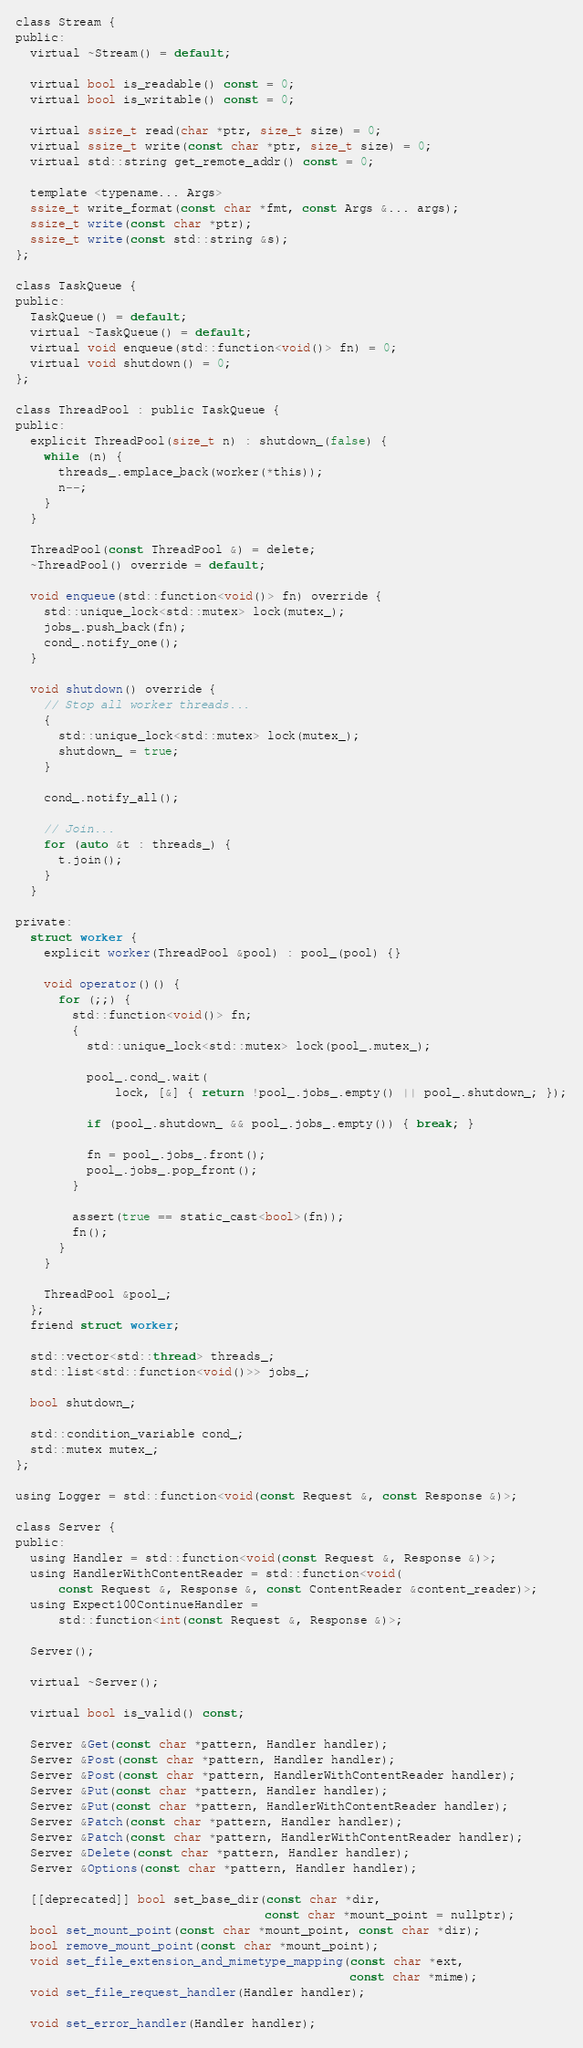Convert code to text. <code><loc_0><loc_0><loc_500><loc_500><_C_>class Stream {
public:
  virtual ~Stream() = default;

  virtual bool is_readable() const = 0;
  virtual bool is_writable() const = 0;

  virtual ssize_t read(char *ptr, size_t size) = 0;
  virtual ssize_t write(const char *ptr, size_t size) = 0;
  virtual std::string get_remote_addr() const = 0;

  template <typename... Args>
  ssize_t write_format(const char *fmt, const Args &... args);
  ssize_t write(const char *ptr);
  ssize_t write(const std::string &s);
};

class TaskQueue {
public:
  TaskQueue() = default;
  virtual ~TaskQueue() = default;
  virtual void enqueue(std::function<void()> fn) = 0;
  virtual void shutdown() = 0;
};

class ThreadPool : public TaskQueue {
public:
  explicit ThreadPool(size_t n) : shutdown_(false) {
    while (n) {
      threads_.emplace_back(worker(*this));
      n--;
    }
  }

  ThreadPool(const ThreadPool &) = delete;
  ~ThreadPool() override = default;

  void enqueue(std::function<void()> fn) override {
    std::unique_lock<std::mutex> lock(mutex_);
    jobs_.push_back(fn);
    cond_.notify_one();
  }

  void shutdown() override {
    // Stop all worker threads...
    {
      std::unique_lock<std::mutex> lock(mutex_);
      shutdown_ = true;
    }

    cond_.notify_all();

    // Join...
    for (auto &t : threads_) {
      t.join();
    }
  }

private:
  struct worker {
    explicit worker(ThreadPool &pool) : pool_(pool) {}

    void operator()() {
      for (;;) {
        std::function<void()> fn;
        {
          std::unique_lock<std::mutex> lock(pool_.mutex_);

          pool_.cond_.wait(
              lock, [&] { return !pool_.jobs_.empty() || pool_.shutdown_; });

          if (pool_.shutdown_ && pool_.jobs_.empty()) { break; }

          fn = pool_.jobs_.front();
          pool_.jobs_.pop_front();
        }

        assert(true == static_cast<bool>(fn));
        fn();
      }
    }

    ThreadPool &pool_;
  };
  friend struct worker;

  std::vector<std::thread> threads_;
  std::list<std::function<void()>> jobs_;

  bool shutdown_;

  std::condition_variable cond_;
  std::mutex mutex_;
};

using Logger = std::function<void(const Request &, const Response &)>;

class Server {
public:
  using Handler = std::function<void(const Request &, Response &)>;
  using HandlerWithContentReader = std::function<void(
      const Request &, Response &, const ContentReader &content_reader)>;
  using Expect100ContinueHandler =
      std::function<int(const Request &, Response &)>;

  Server();

  virtual ~Server();

  virtual bool is_valid() const;

  Server &Get(const char *pattern, Handler handler);
  Server &Post(const char *pattern, Handler handler);
  Server &Post(const char *pattern, HandlerWithContentReader handler);
  Server &Put(const char *pattern, Handler handler);
  Server &Put(const char *pattern, HandlerWithContentReader handler);
  Server &Patch(const char *pattern, Handler handler);
  Server &Patch(const char *pattern, HandlerWithContentReader handler);
  Server &Delete(const char *pattern, Handler handler);
  Server &Options(const char *pattern, Handler handler);

  [[deprecated]] bool set_base_dir(const char *dir,
                                   const char *mount_point = nullptr);
  bool set_mount_point(const char *mount_point, const char *dir);
  bool remove_mount_point(const char *mount_point);
  void set_file_extension_and_mimetype_mapping(const char *ext,
                                               const char *mime);
  void set_file_request_handler(Handler handler);

  void set_error_handler(Handler handler);</code> 